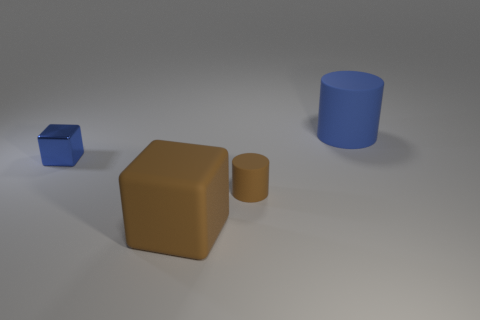Is there anything else that is made of the same material as the blue block?
Your answer should be very brief. No. Is the size of the blue object to the right of the matte cube the same as the brown rubber cube?
Give a very brief answer. Yes. Is the number of large matte blocks right of the matte block the same as the number of small blue shiny cylinders?
Keep it short and to the point. Yes. How many objects are matte things in front of the big blue rubber thing or big brown things?
Provide a succinct answer. 2. There is a object that is to the right of the tiny blue block and behind the small cylinder; what is its shape?
Ensure brevity in your answer.  Cylinder. What number of things are brown objects that are to the left of the tiny brown object or blue things that are left of the small brown cylinder?
Provide a short and direct response. 2. How many other things are the same size as the brown cube?
Offer a terse response. 1. There is a thing behind the tiny blue thing; is its color the same as the metal cube?
Offer a terse response. Yes. What size is the object that is to the left of the tiny rubber cylinder and in front of the tiny blue metal thing?
Offer a very short reply. Large. How many tiny objects are either purple shiny blocks or shiny blocks?
Give a very brief answer. 1. 